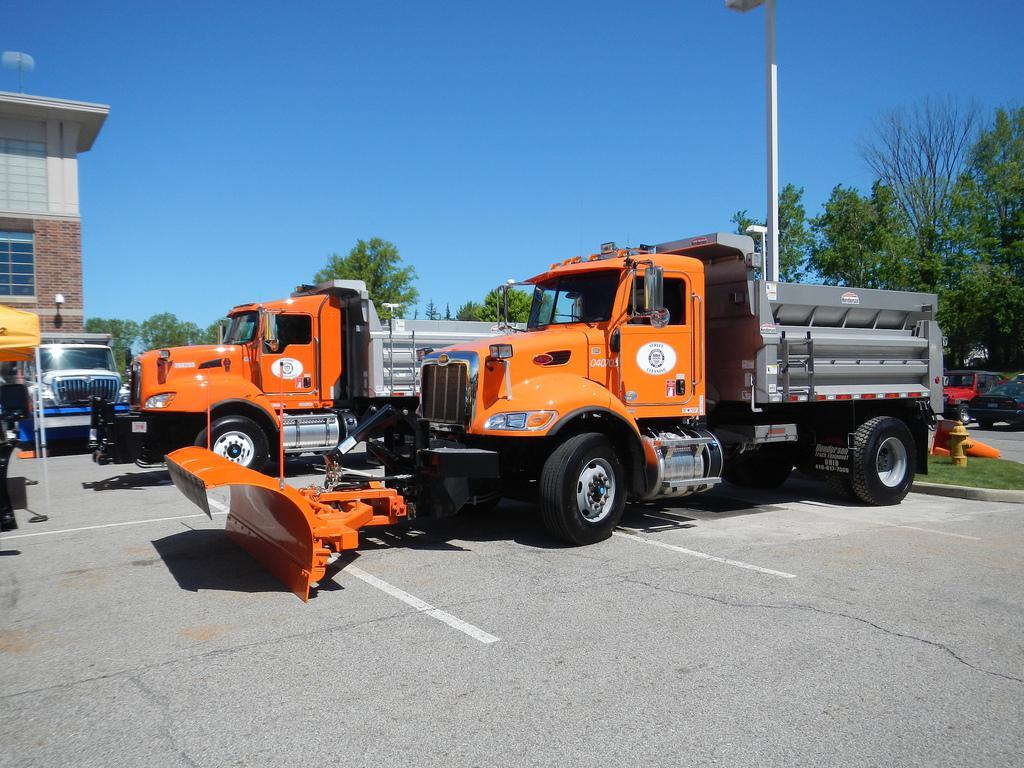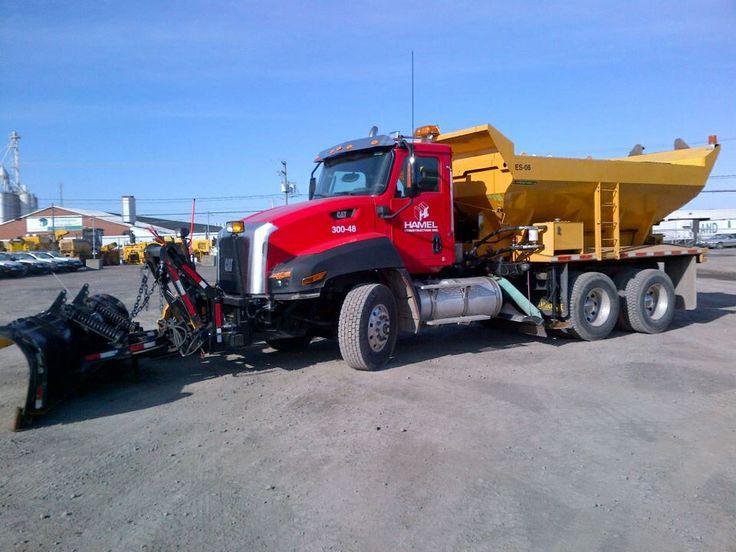The first image is the image on the left, the second image is the image on the right. For the images displayed, is the sentence "one of the trucks is red" factually correct? Answer yes or no. Yes. 